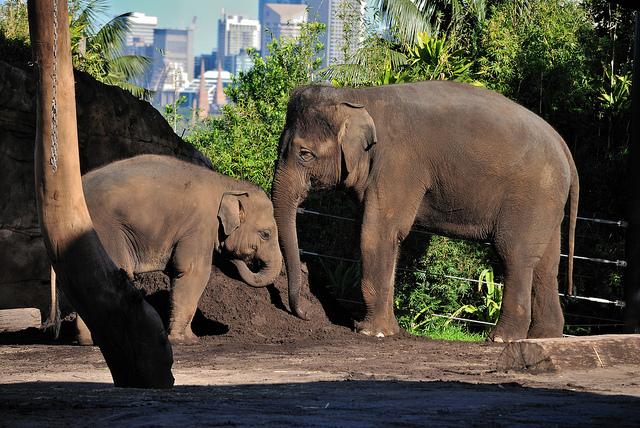Is the elephants trunk holding the other elephants tail?
Write a very short answer. No. What is this baby elephant doing?
Be succinct. Standing. Are these animals facing each other?
Answer briefly. Yes. Are the animals in their natural habitat?
Keep it brief. No. Is there a city nearby?
Short answer required. Yes. How many elephants are in the scene?
Keep it brief. 2. Are these elephants near civilization?
Give a very brief answer. Yes. Are the elephants sleeping?
Keep it brief. No. Which of these elephants is the youngest?
Be succinct. Left. How many elephants are there?
Write a very short answer. 2. Is there a mother elephant in the picture?
Keep it brief. Yes. 